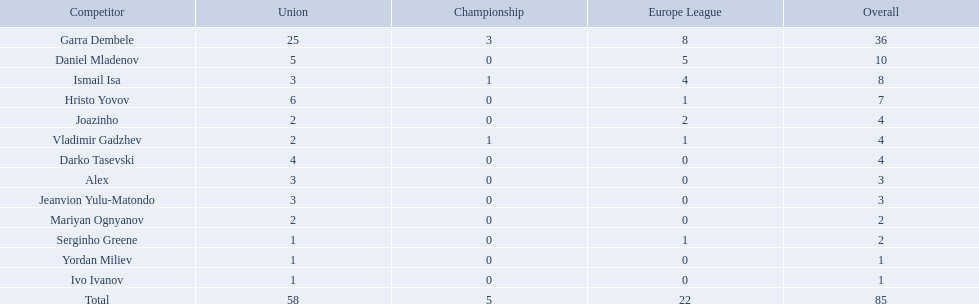What players did not score in all 3 competitions? Daniel Mladenov, Hristo Yovov, Joazinho, Darko Tasevski, Alex, Jeanvion Yulu-Matondo, Mariyan Ognyanov, Serginho Greene, Yordan Miliev, Ivo Ivanov. Which of those did not have total more then 5? Darko Tasevski, Alex, Jeanvion Yulu-Matondo, Mariyan Ognyanov, Serginho Greene, Yordan Miliev, Ivo Ivanov. Which ones scored more then 1 total? Darko Tasevski, Alex, Jeanvion Yulu-Matondo, Mariyan Ognyanov. Which of these player had the lease league points? Mariyan Ognyanov. 